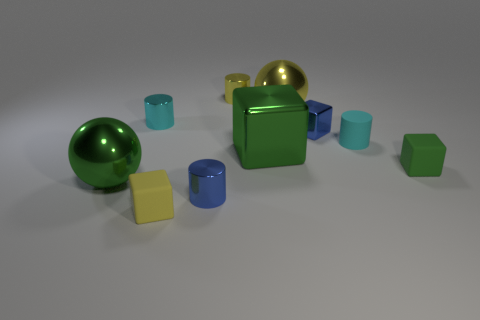How many objects in the scene are not cubes? In the scene, there are two objects that are not cubes: the large green sphere and a smaller cyan cylinder. 